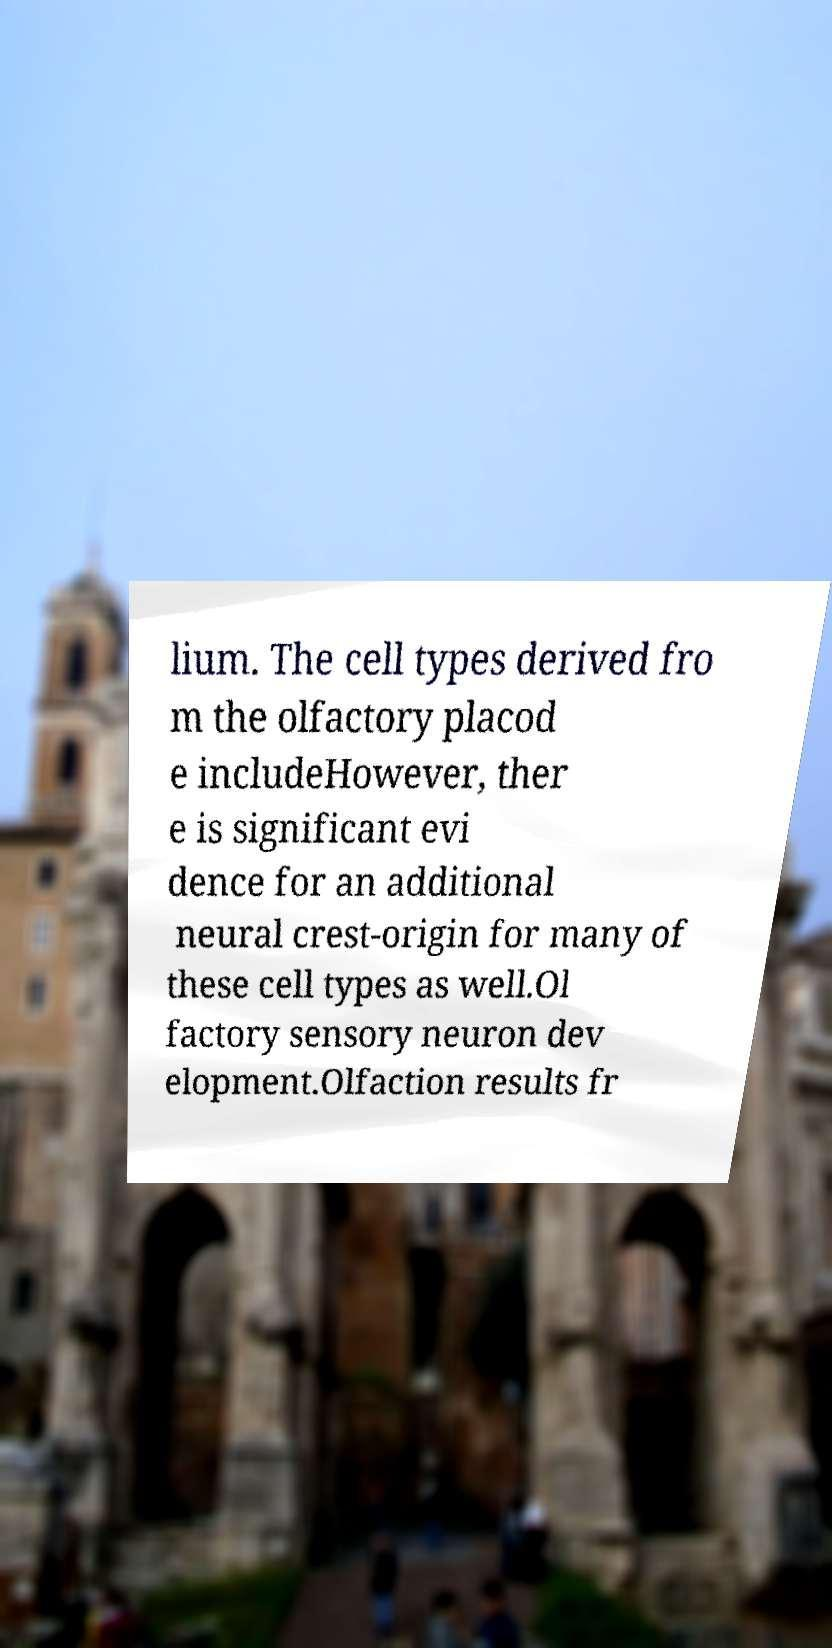What messages or text are displayed in this image? I need them in a readable, typed format. lium. The cell types derived fro m the olfactory placod e includeHowever, ther e is significant evi dence for an additional neural crest-origin for many of these cell types as well.Ol factory sensory neuron dev elopment.Olfaction results fr 